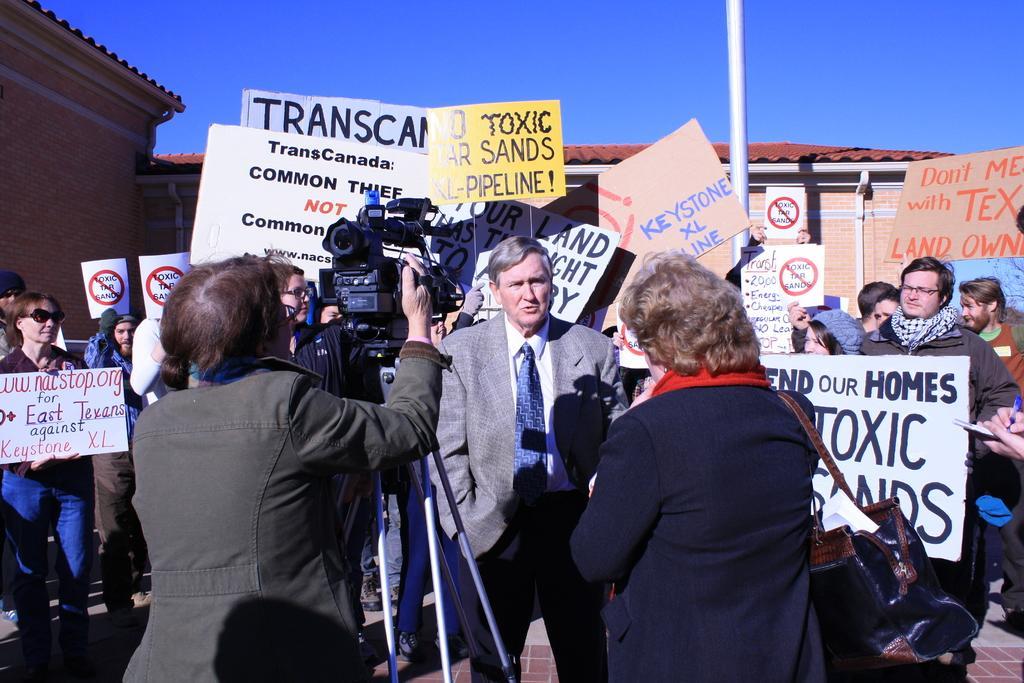In one or two sentences, can you explain what this image depicts? In this picture I can see three persons standing, there is a camera on the tripod stand , there are group of people standing and holding the placards, there is a house, and in the background there is sky. 